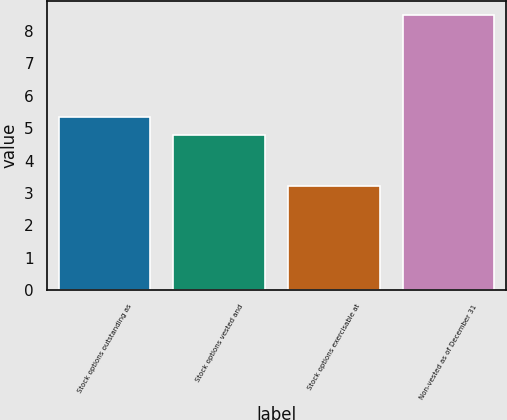Convert chart. <chart><loc_0><loc_0><loc_500><loc_500><bar_chart><fcel>Stock options outstanding as<fcel>Stock options vested and<fcel>Stock options exercisable at<fcel>Non-vested as of December 31<nl><fcel>5.33<fcel>4.8<fcel>3.2<fcel>8.5<nl></chart> 